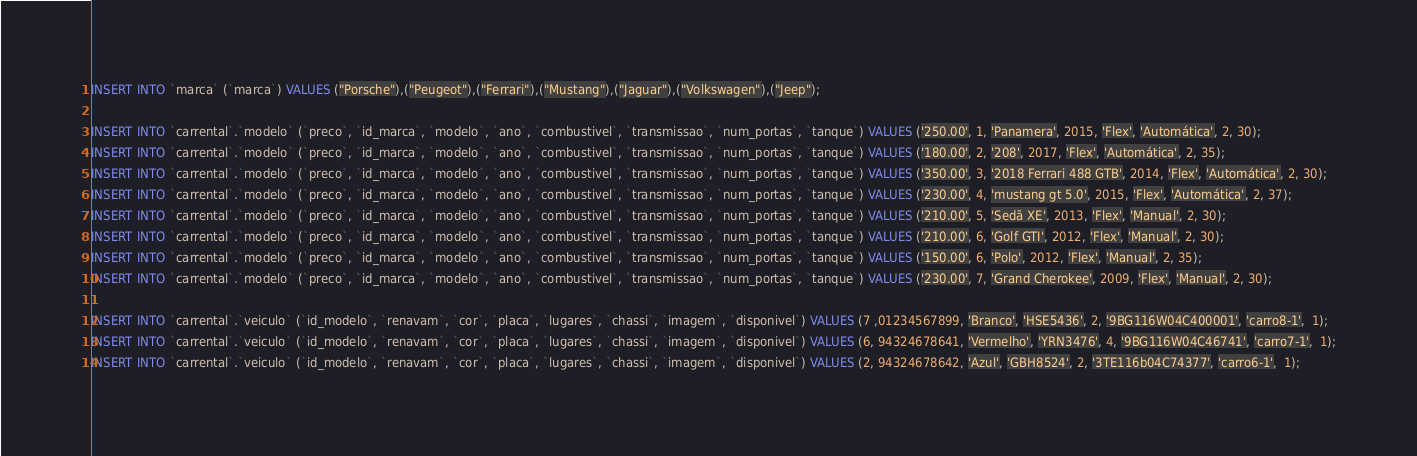<code> <loc_0><loc_0><loc_500><loc_500><_SQL_>INSERT INTO `marca` (`marca`) VALUES ("Porsche"),("Peugeot"),("Ferrari"),("Mustang"),("Jaguar"),("Volkswagen"),("Jeep");

INSERT INTO `carrental`.`modelo` (`preco`, `id_marca`, `modelo`, `ano`, `combustivel`, `transmissao`, `num_portas`, `tanque`) VALUES ('250.00', 1, 'Panamera', 2015, 'Flex', 'Automática', 2, 30);
INSERT INTO `carrental`.`modelo` (`preco`, `id_marca`, `modelo`, `ano`, `combustivel`, `transmissao`, `num_portas`, `tanque`) VALUES ('180.00', 2, '208', 2017, 'Flex', 'Automática', 2, 35);
INSERT INTO `carrental`.`modelo` (`preco`, `id_marca`, `modelo`, `ano`, `combustivel`, `transmissao`, `num_portas`, `tanque`) VALUES ('350.00', 3, '2018 Ferrari 488 GTB', 2014, 'Flex', 'Automática', 2, 30);
INSERT INTO `carrental`.`modelo` (`preco`, `id_marca`, `modelo`, `ano`, `combustivel`, `transmissao`, `num_portas`, `tanque`) VALUES ('230.00', 4, 'mustang gt 5.0', 2015, 'Flex', 'Automática', 2, 37);
INSERT INTO `carrental`.`modelo` (`preco`, `id_marca`, `modelo`, `ano`, `combustivel`, `transmissao`, `num_portas`, `tanque`) VALUES ('210.00', 5, 'Sedã XE', 2013, 'Flex', 'Manual', 2, 30);
INSERT INTO `carrental`.`modelo` (`preco`, `id_marca`, `modelo`, `ano`, `combustivel`, `transmissao`, `num_portas`, `tanque`) VALUES ('210.00', 6, 'Golf GTI', 2012, 'Flex', 'Manual', 2, 30);
INSERT INTO `carrental`.`modelo` (`preco`, `id_marca`, `modelo`, `ano`, `combustivel`, `transmissao`, `num_portas`, `tanque`) VALUES ('150.00', 6, 'Polo', 2012, 'Flex', 'Manual', 2, 35);
INSERT INTO `carrental`.`modelo` (`preco`, `id_marca`, `modelo`, `ano`, `combustivel`, `transmissao`, `num_portas`, `tanque`) VALUES ('230.00', 7, 'Grand Cherokee', 2009, 'Flex', 'Manual', 2, 30);

INSERT INTO `carrental`.`veiculo` (`id_modelo`, `renavam`, `cor`, `placa`, `lugares`, `chassi`, `imagem`, `disponivel`) VALUES (7 ,01234567899, 'Branco', 'HSE5436', 2, '9BG116W04C400001', 'carro8-1',  1);
INSERT INTO `carrental`.`veiculo` (`id_modelo`, `renavam`, `cor`, `placa`, `lugares`, `chassi`, `imagem`, `disponivel`) VALUES (6, 94324678641, 'Vermelho', 'YRN3476', 4, '9BG116W04C46741', 'carro7-1',  1);
INSERT INTO `carrental`.`veiculo` (`id_modelo`, `renavam`, `cor`, `placa`, `lugares`, `chassi`, `imagem`, `disponivel`) VALUES (2, 94324678642, 'Azul', 'GBH8524', 2, '3TE116b04C74377', 'carro6-1',  1);</code> 